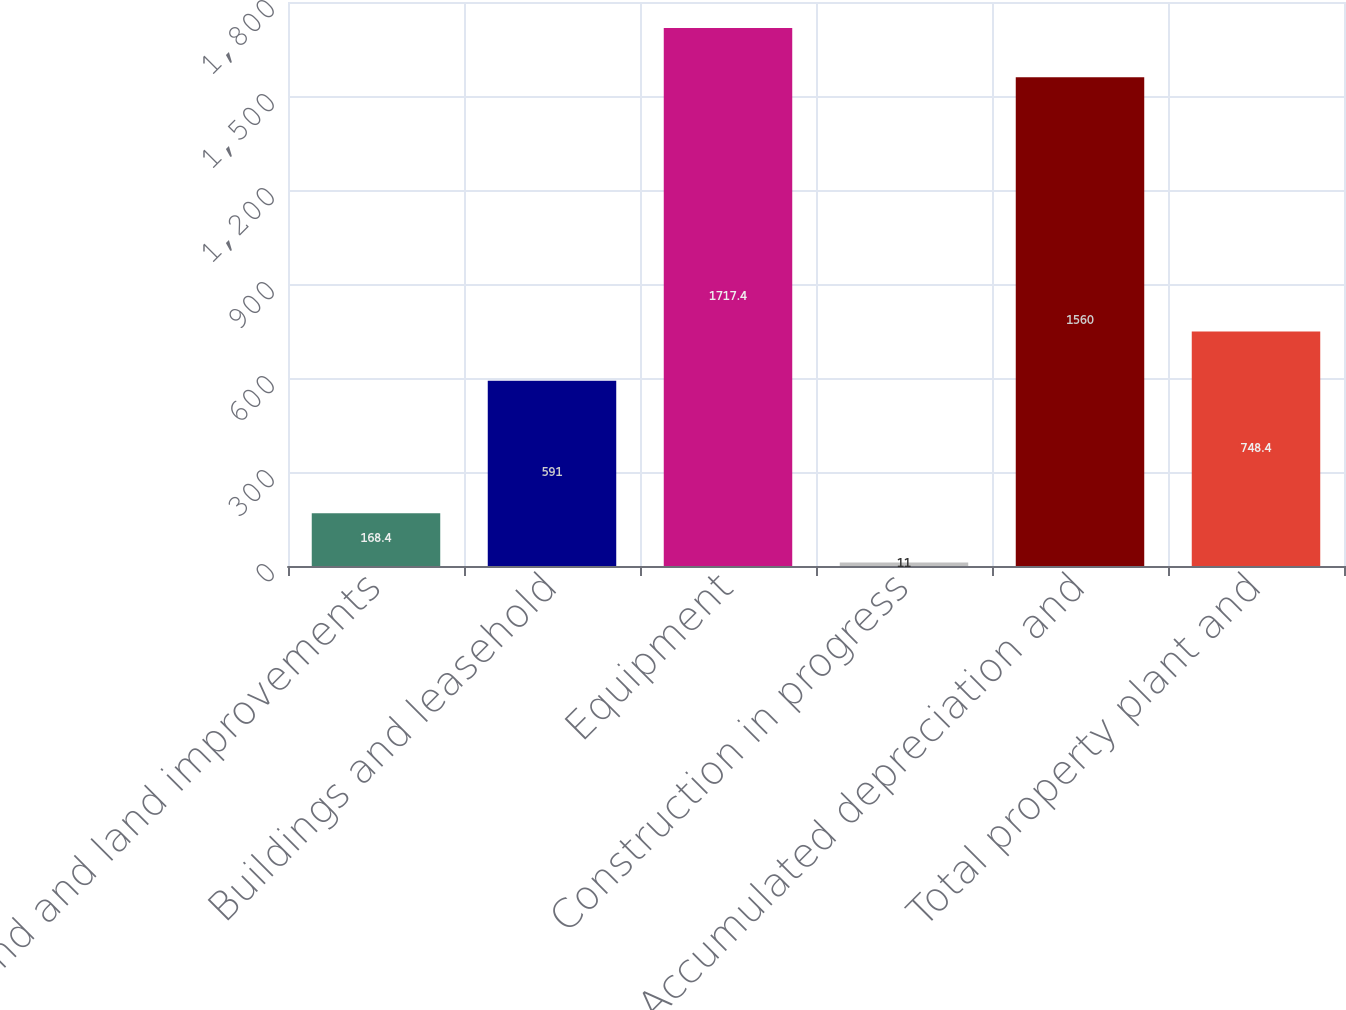Convert chart to OTSL. <chart><loc_0><loc_0><loc_500><loc_500><bar_chart><fcel>Land and land improvements<fcel>Buildings and leasehold<fcel>Equipment<fcel>Construction in progress<fcel>Accumulated depreciation and<fcel>Total property plant and<nl><fcel>168.4<fcel>591<fcel>1717.4<fcel>11<fcel>1560<fcel>748.4<nl></chart> 